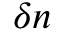<formula> <loc_0><loc_0><loc_500><loc_500>\delta n</formula> 